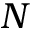<formula> <loc_0><loc_0><loc_500><loc_500>N</formula> 